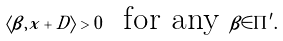<formula> <loc_0><loc_0><loc_500><loc_500>\langle \beta , x + D \rangle > 0 \ \text { for any } \beta \in \Pi ^ { \prime } .</formula> 